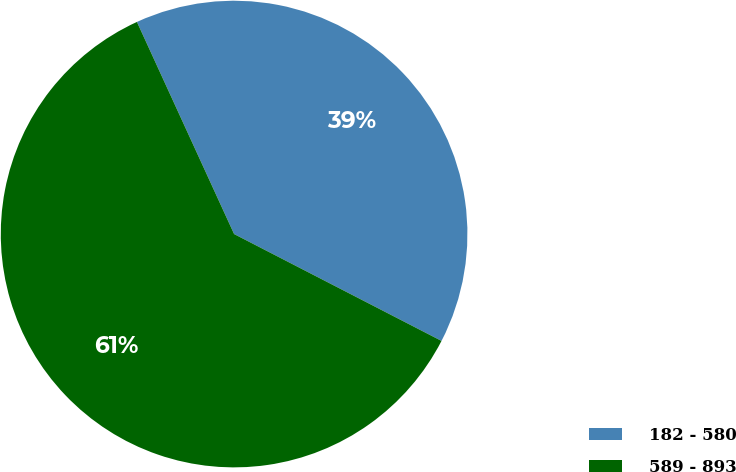<chart> <loc_0><loc_0><loc_500><loc_500><pie_chart><fcel>182 - 580<fcel>589 - 893<nl><fcel>39.41%<fcel>60.59%<nl></chart> 